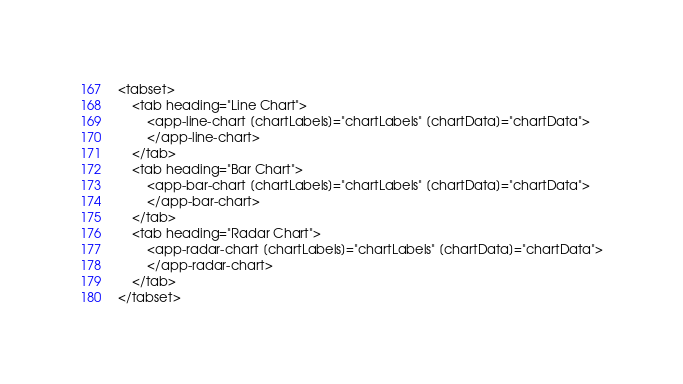Convert code to text. <code><loc_0><loc_0><loc_500><loc_500><_HTML_><tabset>
    <tab heading="Line Chart">
        <app-line-chart [chartLabels]="chartLabels" [chartData]="chartData">
        </app-line-chart>
    </tab>
    <tab heading="Bar Chart">
        <app-bar-chart [chartLabels]="chartLabels" [chartData]="chartData">
        </app-bar-chart>
    </tab>
    <tab heading="Radar Chart">
        <app-radar-chart [chartLabels]="chartLabels" [chartData]="chartData">
        </app-radar-chart>
    </tab>
</tabset>
</code> 